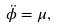Convert formula to latex. <formula><loc_0><loc_0><loc_500><loc_500>\ddot { \phi } = \mu ,</formula> 